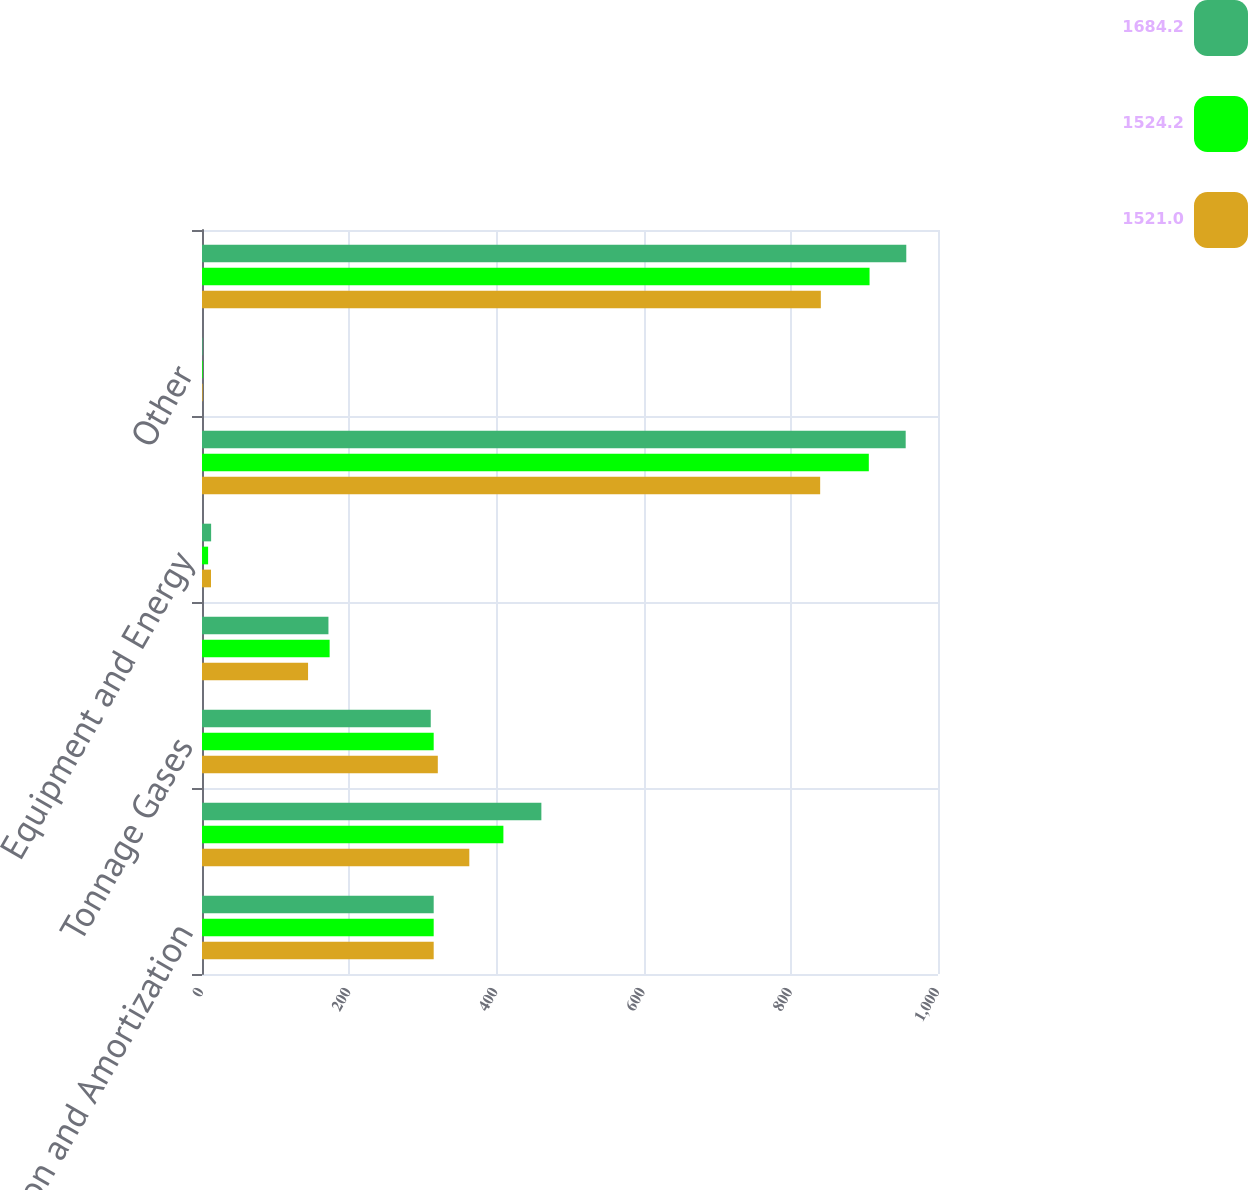Convert chart to OTSL. <chart><loc_0><loc_0><loc_500><loc_500><stacked_bar_chart><ecel><fcel>Depreciation and Amortization<fcel>Merchant Gases<fcel>Tonnage Gases<fcel>Electronics and Performance<fcel>Equipment and Energy<fcel>Segment total<fcel>Other<fcel>Consolidated Total<nl><fcel>1684.2<fcel>314.8<fcel>461.1<fcel>310.8<fcel>171.8<fcel>12.4<fcel>956.1<fcel>0.8<fcel>956.9<nl><fcel>1524.2<fcel>314.8<fcel>409.5<fcel>314.8<fcel>173.4<fcel>8.3<fcel>906<fcel>1<fcel>907<nl><fcel>1521<fcel>314.8<fcel>363.2<fcel>320.4<fcel>144.1<fcel>12.2<fcel>839.9<fcel>0.9<fcel>840.8<nl></chart> 